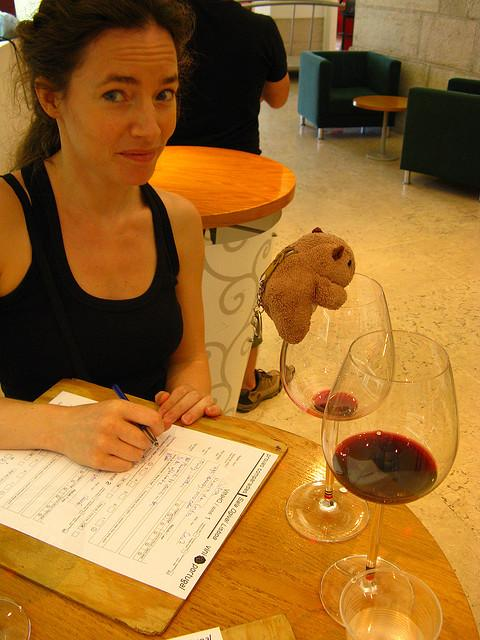What does it look like the stuffed animal is doing? climbing 